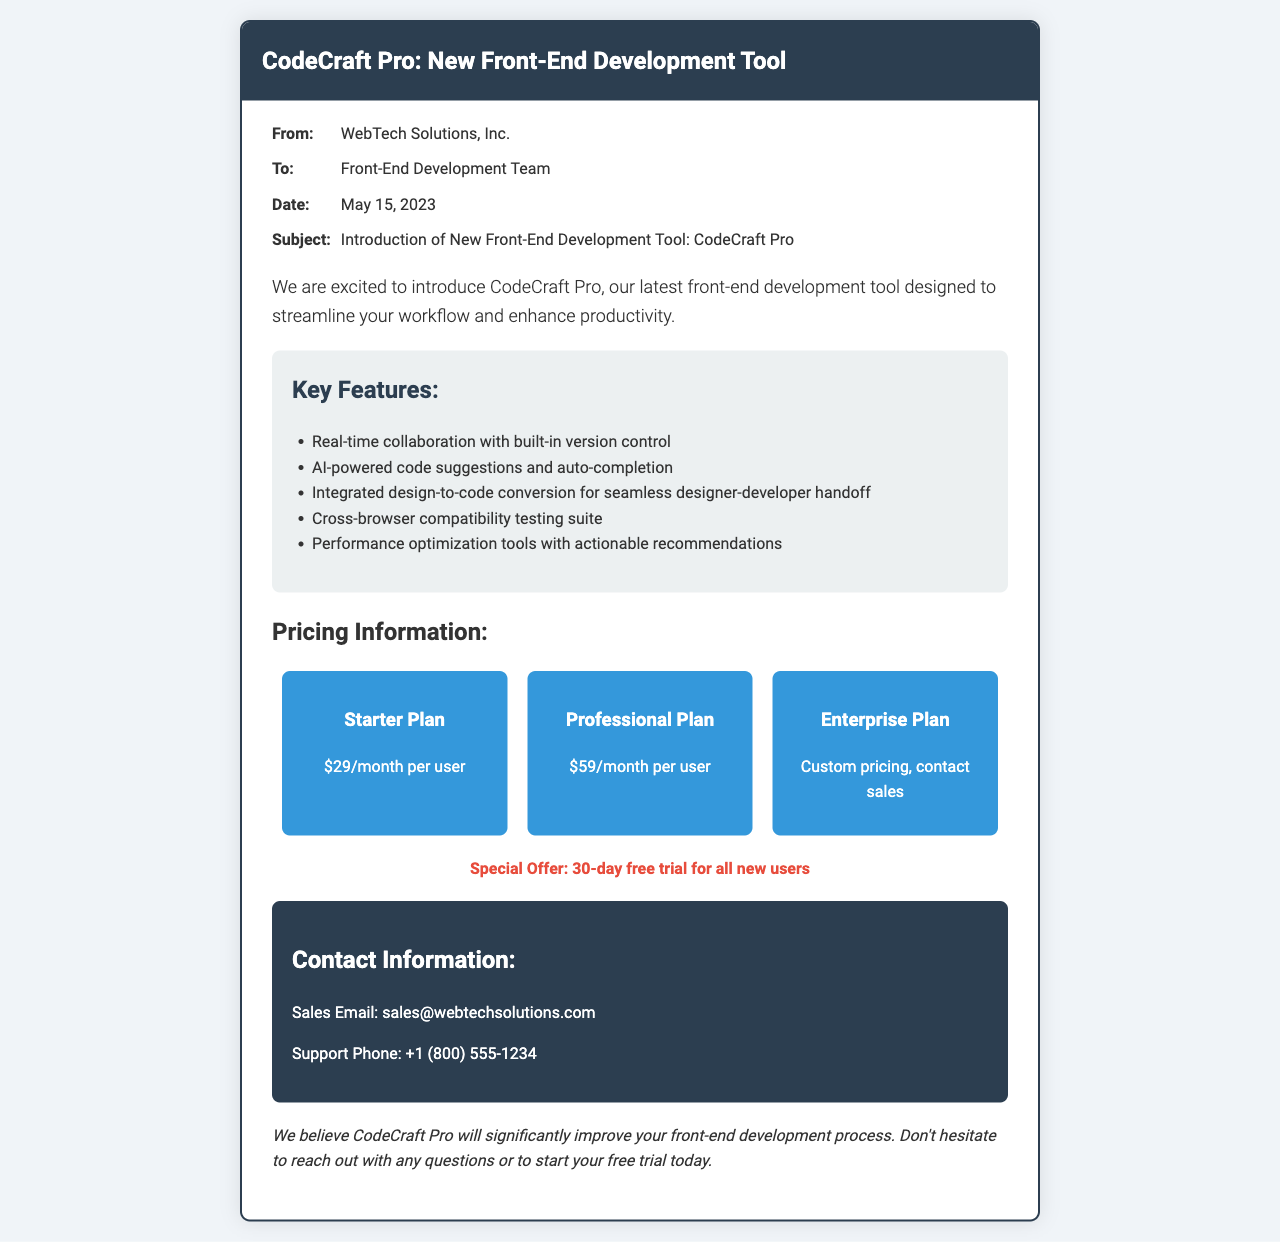What is the name of the new tool? The document introduces a new front-end development tool called CodeCraft Pro.
Answer: CodeCraft Pro Who is the sender of the fax? The fax is sent by WebTech Solutions, Inc.
Answer: WebTech Solutions, Inc What is the date of the fax? The fax was sent on May 15, 2023.
Answer: May 15, 2023 What is the price of the Professional Plan? The Professional Plan is priced at $59 per month per user.
Answer: $59/month per user What special offer is mentioned in the fax? The fax mentions a special offer of a 30-day free trial for all new users.
Answer: 30-day free trial What feature enables seamless designer-developer handoff? The integrated design-to-code conversion allows for seamless designer-developer handoff.
Answer: Integrated design-to-code conversion How many plans are offered? There are three plans offered in total.
Answer: Three What is the primary function of CodeCraft Pro? CodeCraft Pro is designed to streamline your workflow and enhance productivity.
Answer: Streamline workflow and enhance productivity 